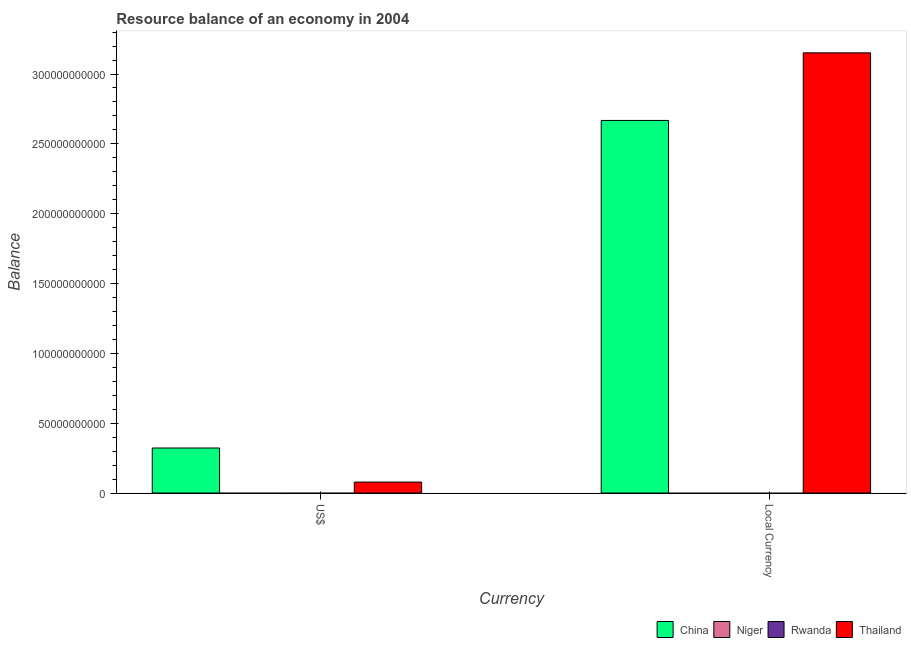How many groups of bars are there?
Ensure brevity in your answer.  2. Are the number of bars on each tick of the X-axis equal?
Offer a terse response. Yes. How many bars are there on the 2nd tick from the left?
Provide a short and direct response. 2. What is the label of the 1st group of bars from the left?
Offer a very short reply. US$. What is the resource balance in constant us$ in Niger?
Offer a very short reply. 0. Across all countries, what is the maximum resource balance in us$?
Keep it short and to the point. 3.22e+1. In which country was the resource balance in us$ maximum?
Your answer should be compact. China. What is the total resource balance in us$ in the graph?
Keep it short and to the point. 4.01e+1. What is the difference between the resource balance in us$ in China and that in Thailand?
Make the answer very short. 2.44e+1. What is the difference between the resource balance in us$ in Niger and the resource balance in constant us$ in Thailand?
Your response must be concise. -3.15e+11. What is the average resource balance in constant us$ per country?
Offer a terse response. 1.45e+11. What is the difference between the resource balance in us$ and resource balance in constant us$ in Thailand?
Your response must be concise. -3.07e+11. In how many countries, is the resource balance in constant us$ greater than the average resource balance in constant us$ taken over all countries?
Provide a succinct answer. 2. How many bars are there?
Provide a short and direct response. 4. How many countries are there in the graph?
Ensure brevity in your answer.  4. Does the graph contain grids?
Give a very brief answer. No. How many legend labels are there?
Make the answer very short. 4. How are the legend labels stacked?
Offer a very short reply. Horizontal. What is the title of the graph?
Your answer should be compact. Resource balance of an economy in 2004. What is the label or title of the X-axis?
Provide a succinct answer. Currency. What is the label or title of the Y-axis?
Your answer should be compact. Balance. What is the Balance in China in US$?
Ensure brevity in your answer.  3.22e+1. What is the Balance in Thailand in US$?
Your answer should be very brief. 7.84e+09. What is the Balance of China in Local Currency?
Keep it short and to the point. 2.67e+11. What is the Balance in Rwanda in Local Currency?
Ensure brevity in your answer.  0. What is the Balance of Thailand in Local Currency?
Your response must be concise. 3.15e+11. Across all Currency, what is the maximum Balance of China?
Your answer should be very brief. 2.67e+11. Across all Currency, what is the maximum Balance of Thailand?
Provide a succinct answer. 3.15e+11. Across all Currency, what is the minimum Balance in China?
Provide a short and direct response. 3.22e+1. Across all Currency, what is the minimum Balance in Thailand?
Give a very brief answer. 7.84e+09. What is the total Balance of China in the graph?
Keep it short and to the point. 2.99e+11. What is the total Balance of Niger in the graph?
Ensure brevity in your answer.  0. What is the total Balance of Thailand in the graph?
Your answer should be compact. 3.23e+11. What is the difference between the Balance of China in US$ and that in Local Currency?
Keep it short and to the point. -2.35e+11. What is the difference between the Balance in Thailand in US$ and that in Local Currency?
Your answer should be compact. -3.07e+11. What is the difference between the Balance in China in US$ and the Balance in Thailand in Local Currency?
Ensure brevity in your answer.  -2.83e+11. What is the average Balance of China per Currency?
Make the answer very short. 1.49e+11. What is the average Balance of Thailand per Currency?
Ensure brevity in your answer.  1.61e+11. What is the difference between the Balance of China and Balance of Thailand in US$?
Provide a succinct answer. 2.44e+1. What is the difference between the Balance in China and Balance in Thailand in Local Currency?
Your response must be concise. -4.84e+1. What is the ratio of the Balance in China in US$ to that in Local Currency?
Provide a short and direct response. 0.12. What is the ratio of the Balance of Thailand in US$ to that in Local Currency?
Give a very brief answer. 0.02. What is the difference between the highest and the second highest Balance in China?
Ensure brevity in your answer.  2.35e+11. What is the difference between the highest and the second highest Balance of Thailand?
Your answer should be compact. 3.07e+11. What is the difference between the highest and the lowest Balance of China?
Give a very brief answer. 2.35e+11. What is the difference between the highest and the lowest Balance of Thailand?
Provide a succinct answer. 3.07e+11. 